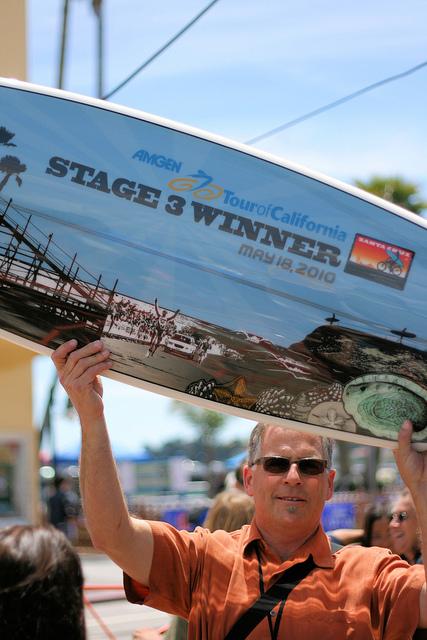What is the man holding?
Answer briefly. Surfboard. What kind of winners is on the board?
Short answer required. Stage 3. What is the man doing?
Short answer required. Holding surfboard. What does the man have around his neck?
Be succinct. Lanyard. 